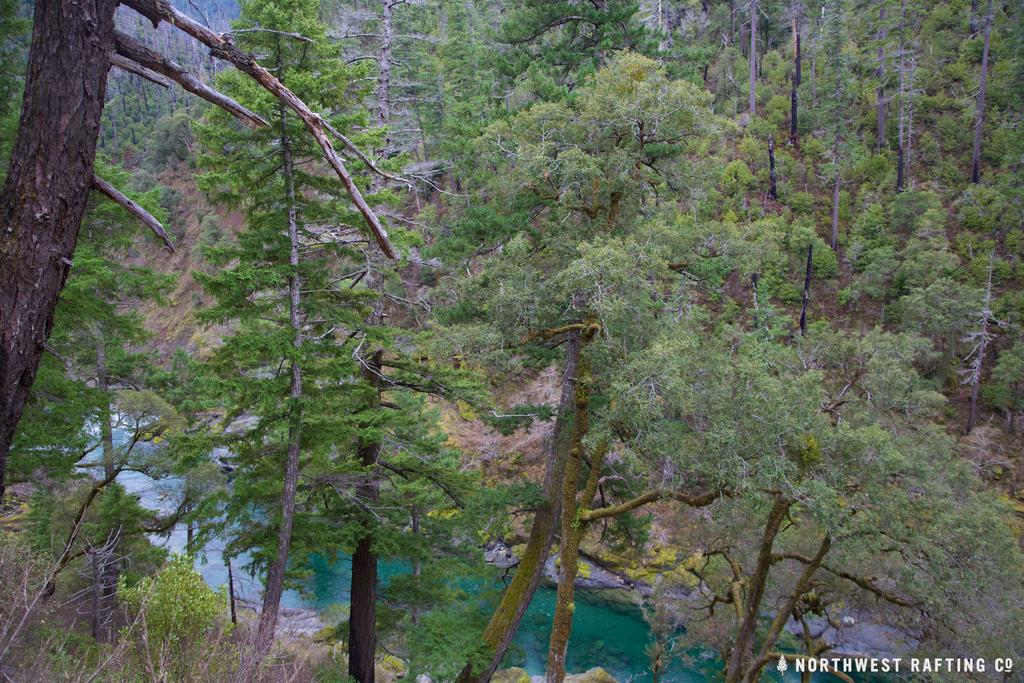What type of landscape is depicted in the image? The image features hills. Are there any plants or vegetation on the hills? Yes, the hills have trees on them. What can be seen between the hills in the image? There is water between the hills. What type of tin can be seen in the image? There is no tin present in the image. How are the trees on the hills sorted in the image? The trees on the hills are not sorted in any particular way; they are naturally distributed. 